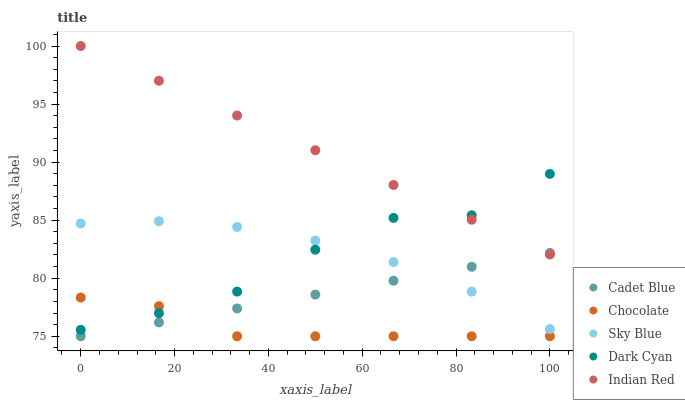Does Chocolate have the minimum area under the curve?
Answer yes or no. Yes. Does Indian Red have the maximum area under the curve?
Answer yes or no. Yes. Does Sky Blue have the minimum area under the curve?
Answer yes or no. No. Does Sky Blue have the maximum area under the curve?
Answer yes or no. No. Is Indian Red the smoothest?
Answer yes or no. Yes. Is Dark Cyan the roughest?
Answer yes or no. Yes. Is Sky Blue the smoothest?
Answer yes or no. No. Is Sky Blue the roughest?
Answer yes or no. No. Does Cadet Blue have the lowest value?
Answer yes or no. Yes. Does Sky Blue have the lowest value?
Answer yes or no. No. Does Indian Red have the highest value?
Answer yes or no. Yes. Does Sky Blue have the highest value?
Answer yes or no. No. Is Sky Blue less than Indian Red?
Answer yes or no. Yes. Is Indian Red greater than Sky Blue?
Answer yes or no. Yes. Does Dark Cyan intersect Sky Blue?
Answer yes or no. Yes. Is Dark Cyan less than Sky Blue?
Answer yes or no. No. Is Dark Cyan greater than Sky Blue?
Answer yes or no. No. Does Sky Blue intersect Indian Red?
Answer yes or no. No. 